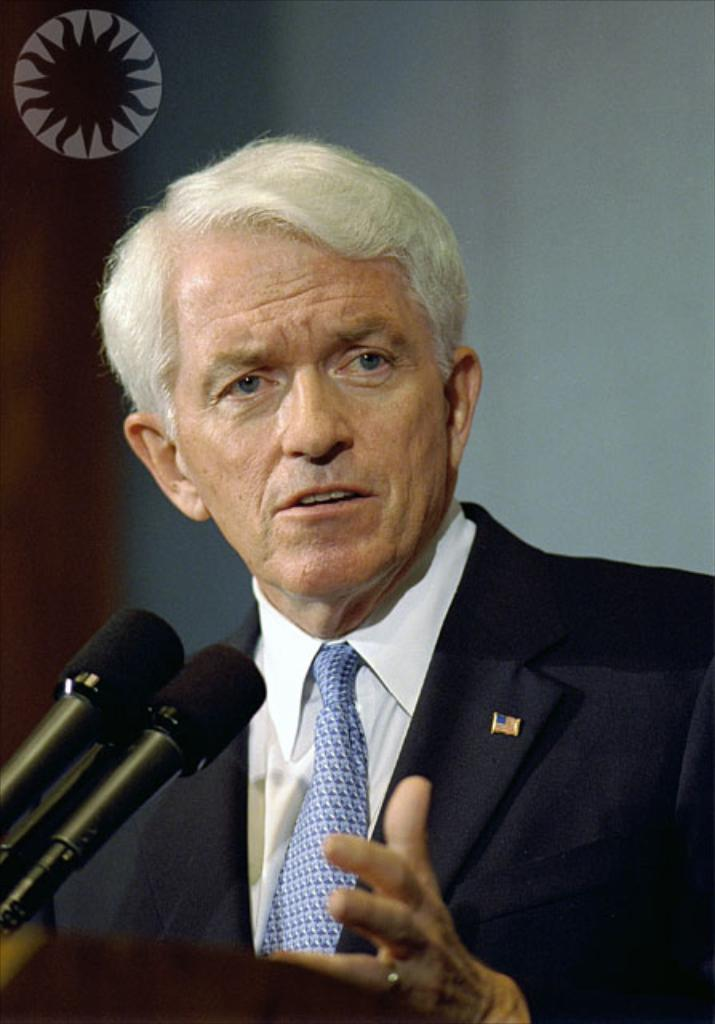What is the main subject of the image? There is a man in the image. What is the man doing in the image? The man is standing at a podium and speaking. What objects are present to amplify the man's voice? There are microphones in the image. What is the color of the background in the image? The background of the image is white. How many things and boys can be seen in the image? There are no things or boys mentioned in the provided facts; the image only features a man at a podium. What book is the man holding in the image? There is no book present in the image; the man is standing at a podium and speaking. 